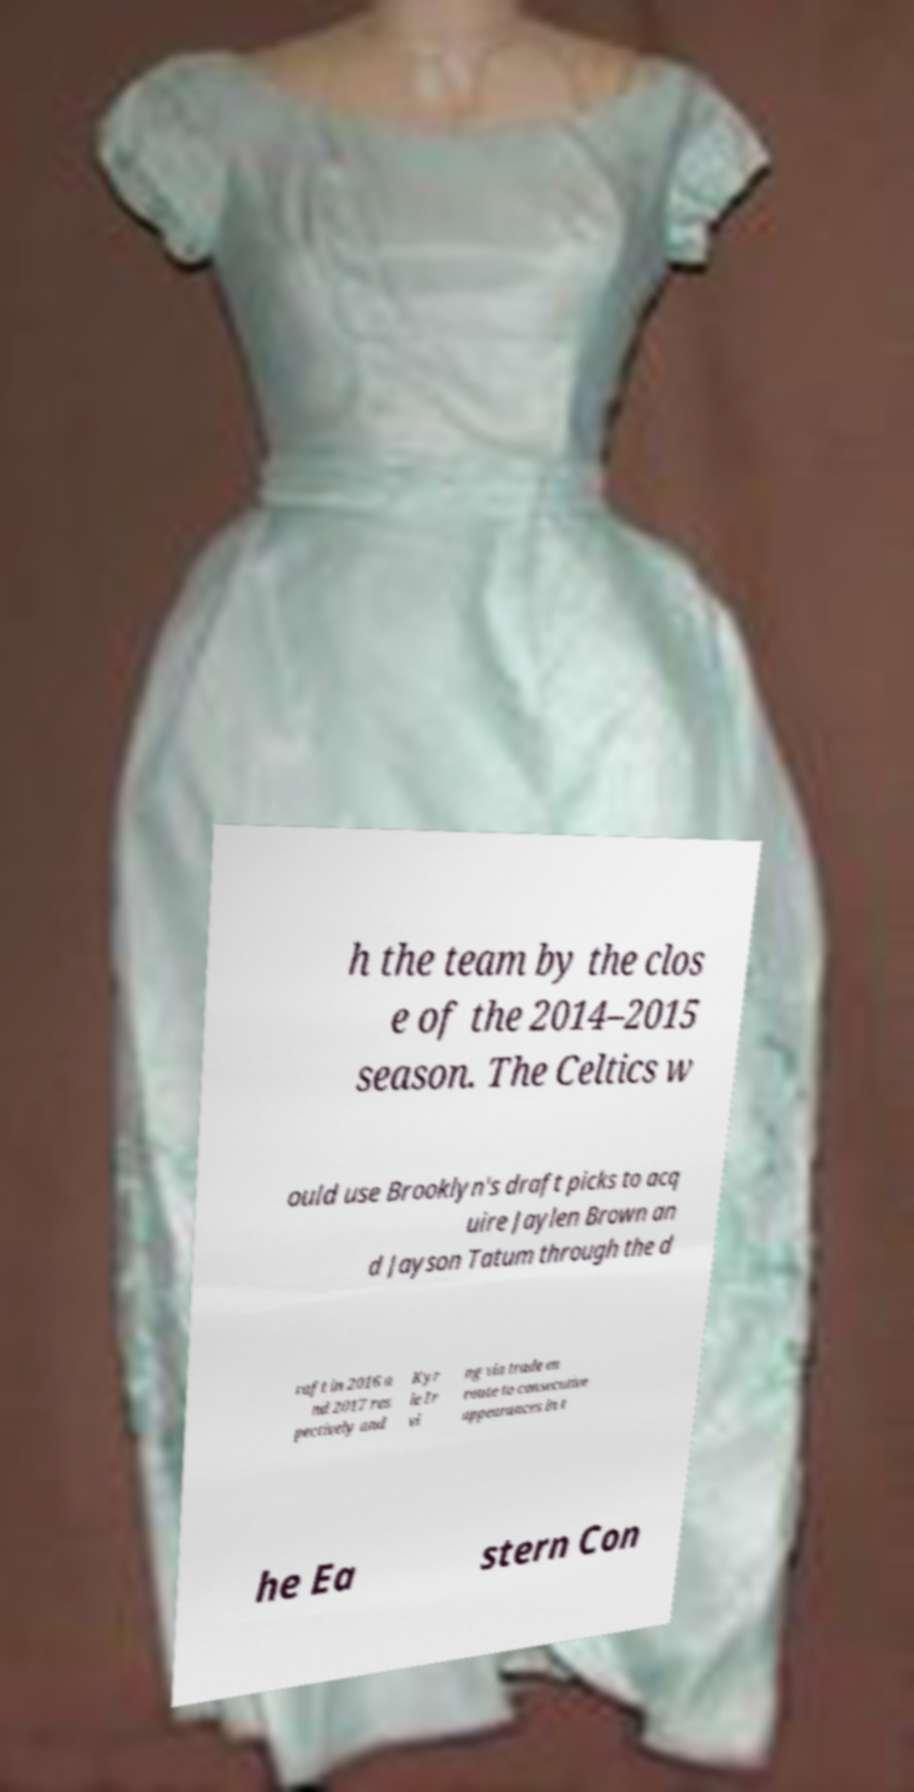Can you read and provide the text displayed in the image?This photo seems to have some interesting text. Can you extract and type it out for me? h the team by the clos e of the 2014–2015 season. The Celtics w ould use Brooklyn's draft picks to acq uire Jaylen Brown an d Jayson Tatum through the d raft in 2016 a nd 2017 res pectively and Kyr ie Ir vi ng via trade en route to consecutive appearances in t he Ea stern Con 